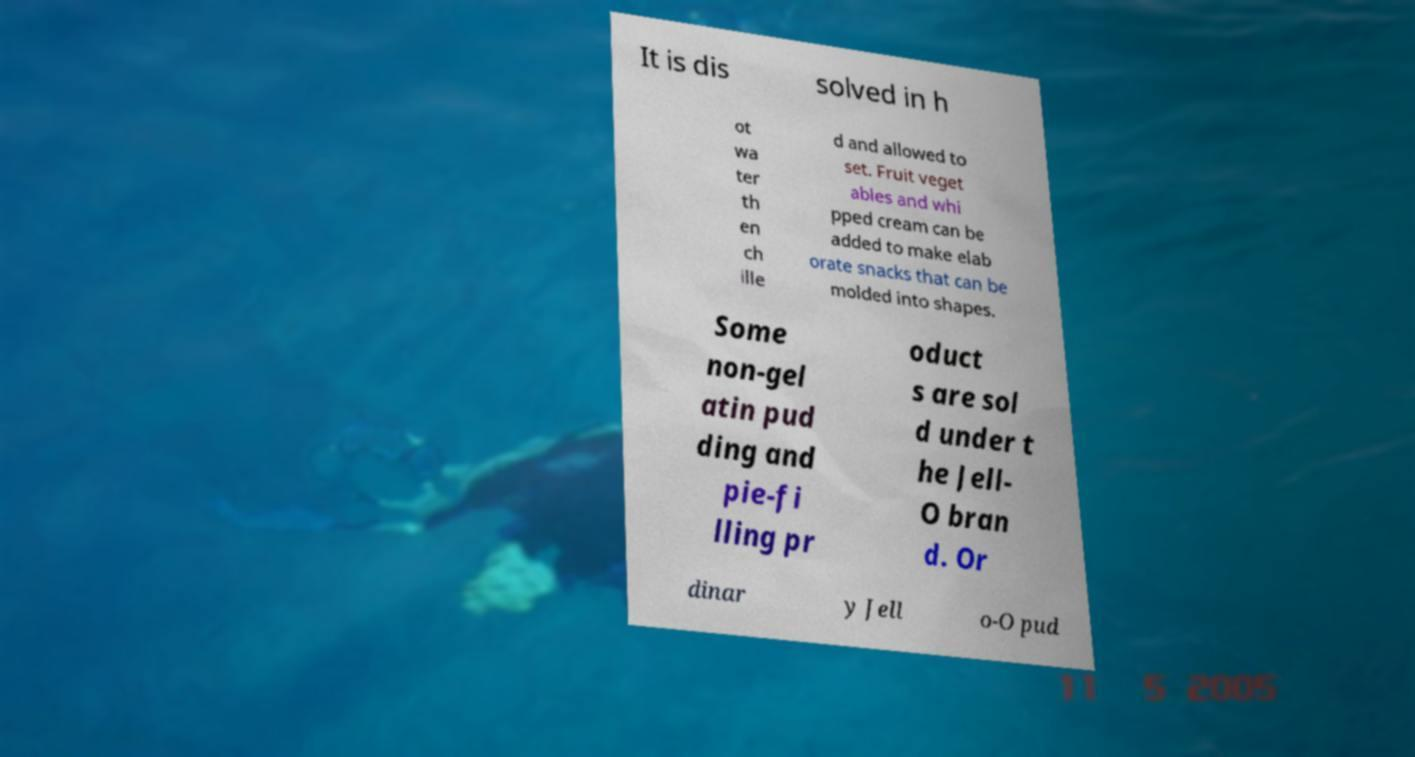Please identify and transcribe the text found in this image. It is dis solved in h ot wa ter th en ch ille d and allowed to set. Fruit veget ables and whi pped cream can be added to make elab orate snacks that can be molded into shapes. Some non-gel atin pud ding and pie-fi lling pr oduct s are sol d under t he Jell- O bran d. Or dinar y Jell o-O pud 